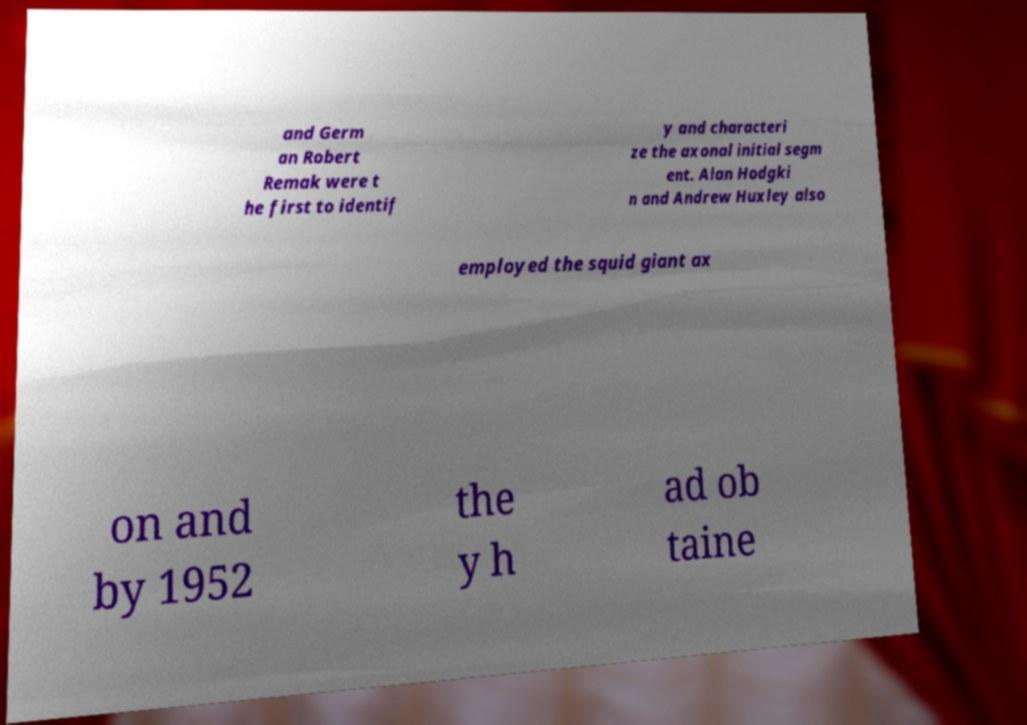What messages or text are displayed in this image? I need them in a readable, typed format. and Germ an Robert Remak were t he first to identif y and characteri ze the axonal initial segm ent. Alan Hodgki n and Andrew Huxley also employed the squid giant ax on and by 1952 the y h ad ob taine 